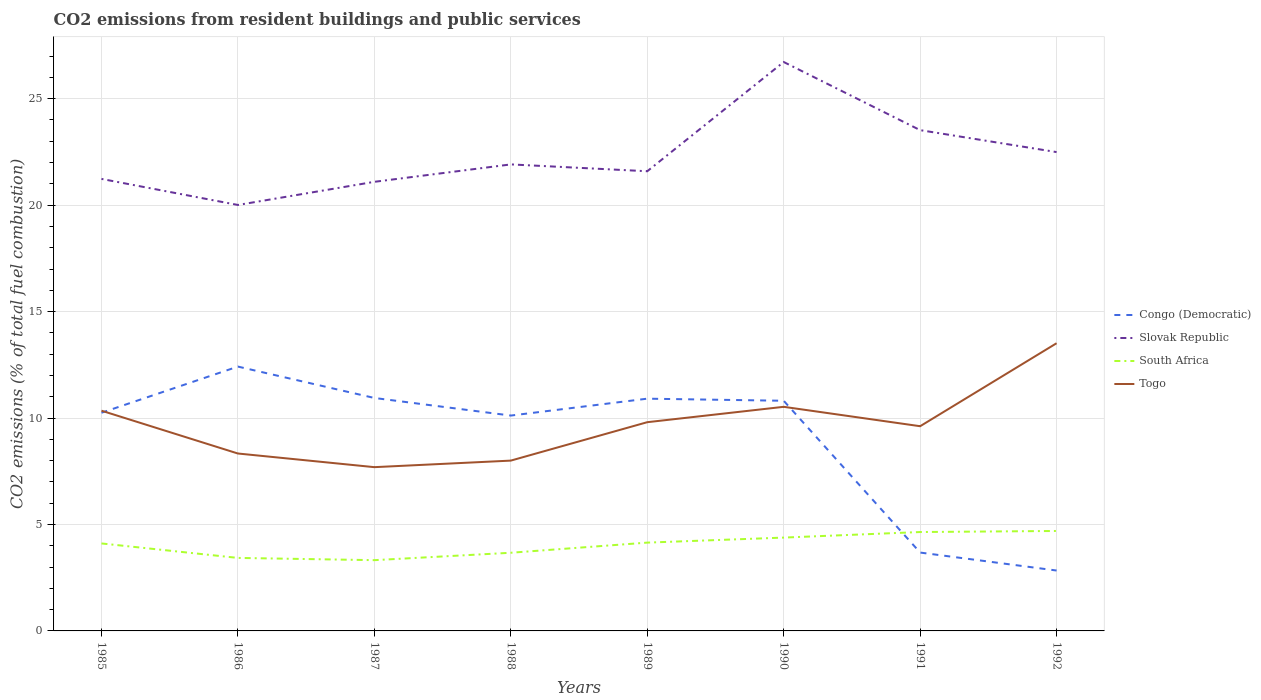How many different coloured lines are there?
Offer a very short reply. 4. Does the line corresponding to Togo intersect with the line corresponding to Slovak Republic?
Ensure brevity in your answer.  No. Across all years, what is the maximum total CO2 emitted in Togo?
Offer a terse response. 7.69. In which year was the total CO2 emitted in Togo maximum?
Ensure brevity in your answer.  1987. What is the total total CO2 emitted in Congo (Democratic) in the graph?
Provide a short and direct response. 1.51. What is the difference between the highest and the second highest total CO2 emitted in Togo?
Keep it short and to the point. 5.82. Is the total CO2 emitted in Togo strictly greater than the total CO2 emitted in Slovak Republic over the years?
Your answer should be compact. Yes. How many lines are there?
Your answer should be compact. 4. How many years are there in the graph?
Offer a very short reply. 8. Where does the legend appear in the graph?
Your response must be concise. Center right. What is the title of the graph?
Offer a very short reply. CO2 emissions from resident buildings and public services. What is the label or title of the Y-axis?
Give a very brief answer. CO2 emissions (% of total fuel combustion). What is the CO2 emissions (% of total fuel combustion) of Congo (Democratic) in 1985?
Provide a succinct answer. 10.25. What is the CO2 emissions (% of total fuel combustion) in Slovak Republic in 1985?
Your answer should be very brief. 21.23. What is the CO2 emissions (% of total fuel combustion) of South Africa in 1985?
Your answer should be compact. 4.11. What is the CO2 emissions (% of total fuel combustion) in Togo in 1985?
Make the answer very short. 10.34. What is the CO2 emissions (% of total fuel combustion) of Congo (Democratic) in 1986?
Give a very brief answer. 12.42. What is the CO2 emissions (% of total fuel combustion) of Slovak Republic in 1986?
Give a very brief answer. 20.01. What is the CO2 emissions (% of total fuel combustion) of South Africa in 1986?
Offer a very short reply. 3.43. What is the CO2 emissions (% of total fuel combustion) in Togo in 1986?
Your answer should be very brief. 8.33. What is the CO2 emissions (% of total fuel combustion) of Congo (Democratic) in 1987?
Give a very brief answer. 10.94. What is the CO2 emissions (% of total fuel combustion) in Slovak Republic in 1987?
Make the answer very short. 21.09. What is the CO2 emissions (% of total fuel combustion) of South Africa in 1987?
Provide a short and direct response. 3.32. What is the CO2 emissions (% of total fuel combustion) of Togo in 1987?
Offer a very short reply. 7.69. What is the CO2 emissions (% of total fuel combustion) in Congo (Democratic) in 1988?
Provide a short and direct response. 10.12. What is the CO2 emissions (% of total fuel combustion) in Slovak Republic in 1988?
Make the answer very short. 21.91. What is the CO2 emissions (% of total fuel combustion) in South Africa in 1988?
Offer a terse response. 3.67. What is the CO2 emissions (% of total fuel combustion) of Congo (Democratic) in 1989?
Your response must be concise. 10.91. What is the CO2 emissions (% of total fuel combustion) in Slovak Republic in 1989?
Your answer should be very brief. 21.59. What is the CO2 emissions (% of total fuel combustion) of South Africa in 1989?
Make the answer very short. 4.15. What is the CO2 emissions (% of total fuel combustion) of Togo in 1989?
Offer a very short reply. 9.8. What is the CO2 emissions (% of total fuel combustion) in Congo (Democratic) in 1990?
Provide a short and direct response. 10.81. What is the CO2 emissions (% of total fuel combustion) in Slovak Republic in 1990?
Make the answer very short. 26.72. What is the CO2 emissions (% of total fuel combustion) in South Africa in 1990?
Ensure brevity in your answer.  4.38. What is the CO2 emissions (% of total fuel combustion) in Togo in 1990?
Your response must be concise. 10.53. What is the CO2 emissions (% of total fuel combustion) in Congo (Democratic) in 1991?
Your answer should be compact. 3.68. What is the CO2 emissions (% of total fuel combustion) of Slovak Republic in 1991?
Your answer should be compact. 23.52. What is the CO2 emissions (% of total fuel combustion) in South Africa in 1991?
Ensure brevity in your answer.  4.65. What is the CO2 emissions (% of total fuel combustion) of Togo in 1991?
Offer a very short reply. 9.62. What is the CO2 emissions (% of total fuel combustion) of Congo (Democratic) in 1992?
Offer a terse response. 2.84. What is the CO2 emissions (% of total fuel combustion) of Slovak Republic in 1992?
Provide a succinct answer. 22.49. What is the CO2 emissions (% of total fuel combustion) of South Africa in 1992?
Keep it short and to the point. 4.69. What is the CO2 emissions (% of total fuel combustion) of Togo in 1992?
Offer a very short reply. 13.51. Across all years, what is the maximum CO2 emissions (% of total fuel combustion) in Congo (Democratic)?
Your answer should be very brief. 12.42. Across all years, what is the maximum CO2 emissions (% of total fuel combustion) of Slovak Republic?
Your answer should be very brief. 26.72. Across all years, what is the maximum CO2 emissions (% of total fuel combustion) in South Africa?
Ensure brevity in your answer.  4.69. Across all years, what is the maximum CO2 emissions (% of total fuel combustion) of Togo?
Keep it short and to the point. 13.51. Across all years, what is the minimum CO2 emissions (% of total fuel combustion) of Congo (Democratic)?
Provide a short and direct response. 2.84. Across all years, what is the minimum CO2 emissions (% of total fuel combustion) in Slovak Republic?
Offer a terse response. 20.01. Across all years, what is the minimum CO2 emissions (% of total fuel combustion) of South Africa?
Your response must be concise. 3.32. Across all years, what is the minimum CO2 emissions (% of total fuel combustion) of Togo?
Make the answer very short. 7.69. What is the total CO2 emissions (% of total fuel combustion) of Congo (Democratic) in the graph?
Give a very brief answer. 71.96. What is the total CO2 emissions (% of total fuel combustion) of Slovak Republic in the graph?
Offer a very short reply. 178.58. What is the total CO2 emissions (% of total fuel combustion) of South Africa in the graph?
Offer a very short reply. 32.41. What is the total CO2 emissions (% of total fuel combustion) in Togo in the graph?
Provide a succinct answer. 77.83. What is the difference between the CO2 emissions (% of total fuel combustion) in Congo (Democratic) in 1985 and that in 1986?
Ensure brevity in your answer.  -2.17. What is the difference between the CO2 emissions (% of total fuel combustion) of Slovak Republic in 1985 and that in 1986?
Give a very brief answer. 1.22. What is the difference between the CO2 emissions (% of total fuel combustion) of South Africa in 1985 and that in 1986?
Make the answer very short. 0.68. What is the difference between the CO2 emissions (% of total fuel combustion) of Togo in 1985 and that in 1986?
Provide a short and direct response. 2.01. What is the difference between the CO2 emissions (% of total fuel combustion) of Congo (Democratic) in 1985 and that in 1987?
Your answer should be compact. -0.69. What is the difference between the CO2 emissions (% of total fuel combustion) in Slovak Republic in 1985 and that in 1987?
Provide a short and direct response. 0.14. What is the difference between the CO2 emissions (% of total fuel combustion) in South Africa in 1985 and that in 1987?
Offer a terse response. 0.79. What is the difference between the CO2 emissions (% of total fuel combustion) in Togo in 1985 and that in 1987?
Provide a short and direct response. 2.65. What is the difference between the CO2 emissions (% of total fuel combustion) in Congo (Democratic) in 1985 and that in 1988?
Keep it short and to the point. 0.13. What is the difference between the CO2 emissions (% of total fuel combustion) in Slovak Republic in 1985 and that in 1988?
Your answer should be very brief. -0.68. What is the difference between the CO2 emissions (% of total fuel combustion) of South Africa in 1985 and that in 1988?
Your answer should be compact. 0.44. What is the difference between the CO2 emissions (% of total fuel combustion) in Togo in 1985 and that in 1988?
Ensure brevity in your answer.  2.34. What is the difference between the CO2 emissions (% of total fuel combustion) in Congo (Democratic) in 1985 and that in 1989?
Your answer should be very brief. -0.66. What is the difference between the CO2 emissions (% of total fuel combustion) in Slovak Republic in 1985 and that in 1989?
Keep it short and to the point. -0.36. What is the difference between the CO2 emissions (% of total fuel combustion) of South Africa in 1985 and that in 1989?
Ensure brevity in your answer.  -0.04. What is the difference between the CO2 emissions (% of total fuel combustion) in Togo in 1985 and that in 1989?
Offer a terse response. 0.54. What is the difference between the CO2 emissions (% of total fuel combustion) of Congo (Democratic) in 1985 and that in 1990?
Make the answer very short. -0.56. What is the difference between the CO2 emissions (% of total fuel combustion) in Slovak Republic in 1985 and that in 1990?
Your response must be concise. -5.49. What is the difference between the CO2 emissions (% of total fuel combustion) in South Africa in 1985 and that in 1990?
Offer a terse response. -0.27. What is the difference between the CO2 emissions (% of total fuel combustion) of Togo in 1985 and that in 1990?
Give a very brief answer. -0.18. What is the difference between the CO2 emissions (% of total fuel combustion) of Congo (Democratic) in 1985 and that in 1991?
Provide a succinct answer. 6.57. What is the difference between the CO2 emissions (% of total fuel combustion) of Slovak Republic in 1985 and that in 1991?
Provide a short and direct response. -2.29. What is the difference between the CO2 emissions (% of total fuel combustion) of South Africa in 1985 and that in 1991?
Give a very brief answer. -0.54. What is the difference between the CO2 emissions (% of total fuel combustion) in Togo in 1985 and that in 1991?
Your answer should be compact. 0.73. What is the difference between the CO2 emissions (% of total fuel combustion) in Congo (Democratic) in 1985 and that in 1992?
Offer a very short reply. 7.41. What is the difference between the CO2 emissions (% of total fuel combustion) in Slovak Republic in 1985 and that in 1992?
Make the answer very short. -1.26. What is the difference between the CO2 emissions (% of total fuel combustion) of South Africa in 1985 and that in 1992?
Provide a succinct answer. -0.59. What is the difference between the CO2 emissions (% of total fuel combustion) of Togo in 1985 and that in 1992?
Make the answer very short. -3.17. What is the difference between the CO2 emissions (% of total fuel combustion) in Congo (Democratic) in 1986 and that in 1987?
Your answer should be compact. 1.47. What is the difference between the CO2 emissions (% of total fuel combustion) of Slovak Republic in 1986 and that in 1987?
Offer a very short reply. -1.09. What is the difference between the CO2 emissions (% of total fuel combustion) in South Africa in 1986 and that in 1987?
Your answer should be very brief. 0.11. What is the difference between the CO2 emissions (% of total fuel combustion) in Togo in 1986 and that in 1987?
Keep it short and to the point. 0.64. What is the difference between the CO2 emissions (% of total fuel combustion) of Congo (Democratic) in 1986 and that in 1988?
Make the answer very short. 2.3. What is the difference between the CO2 emissions (% of total fuel combustion) of Slovak Republic in 1986 and that in 1988?
Your answer should be compact. -1.91. What is the difference between the CO2 emissions (% of total fuel combustion) of South Africa in 1986 and that in 1988?
Offer a very short reply. -0.24. What is the difference between the CO2 emissions (% of total fuel combustion) of Congo (Democratic) in 1986 and that in 1989?
Your answer should be very brief. 1.51. What is the difference between the CO2 emissions (% of total fuel combustion) of Slovak Republic in 1986 and that in 1989?
Provide a short and direct response. -1.58. What is the difference between the CO2 emissions (% of total fuel combustion) in South Africa in 1986 and that in 1989?
Provide a short and direct response. -0.72. What is the difference between the CO2 emissions (% of total fuel combustion) in Togo in 1986 and that in 1989?
Your response must be concise. -1.47. What is the difference between the CO2 emissions (% of total fuel combustion) in Congo (Democratic) in 1986 and that in 1990?
Your response must be concise. 1.61. What is the difference between the CO2 emissions (% of total fuel combustion) of Slovak Republic in 1986 and that in 1990?
Provide a succinct answer. -6.72. What is the difference between the CO2 emissions (% of total fuel combustion) in South Africa in 1986 and that in 1990?
Your response must be concise. -0.95. What is the difference between the CO2 emissions (% of total fuel combustion) of Togo in 1986 and that in 1990?
Your response must be concise. -2.19. What is the difference between the CO2 emissions (% of total fuel combustion) in Congo (Democratic) in 1986 and that in 1991?
Provide a succinct answer. 8.74. What is the difference between the CO2 emissions (% of total fuel combustion) in Slovak Republic in 1986 and that in 1991?
Offer a terse response. -3.51. What is the difference between the CO2 emissions (% of total fuel combustion) of South Africa in 1986 and that in 1991?
Provide a succinct answer. -1.22. What is the difference between the CO2 emissions (% of total fuel combustion) in Togo in 1986 and that in 1991?
Offer a terse response. -1.28. What is the difference between the CO2 emissions (% of total fuel combustion) of Congo (Democratic) in 1986 and that in 1992?
Your answer should be very brief. 9.58. What is the difference between the CO2 emissions (% of total fuel combustion) of Slovak Republic in 1986 and that in 1992?
Provide a succinct answer. -2.48. What is the difference between the CO2 emissions (% of total fuel combustion) in South Africa in 1986 and that in 1992?
Make the answer very short. -1.27. What is the difference between the CO2 emissions (% of total fuel combustion) in Togo in 1986 and that in 1992?
Your response must be concise. -5.18. What is the difference between the CO2 emissions (% of total fuel combustion) of Congo (Democratic) in 1987 and that in 1988?
Provide a succinct answer. 0.83. What is the difference between the CO2 emissions (% of total fuel combustion) in Slovak Republic in 1987 and that in 1988?
Give a very brief answer. -0.82. What is the difference between the CO2 emissions (% of total fuel combustion) in South Africa in 1987 and that in 1988?
Keep it short and to the point. -0.35. What is the difference between the CO2 emissions (% of total fuel combustion) of Togo in 1987 and that in 1988?
Provide a short and direct response. -0.31. What is the difference between the CO2 emissions (% of total fuel combustion) in Congo (Democratic) in 1987 and that in 1989?
Offer a very short reply. 0.03. What is the difference between the CO2 emissions (% of total fuel combustion) in Slovak Republic in 1987 and that in 1989?
Offer a very short reply. -0.5. What is the difference between the CO2 emissions (% of total fuel combustion) in South Africa in 1987 and that in 1989?
Keep it short and to the point. -0.82. What is the difference between the CO2 emissions (% of total fuel combustion) in Togo in 1987 and that in 1989?
Your response must be concise. -2.11. What is the difference between the CO2 emissions (% of total fuel combustion) of Congo (Democratic) in 1987 and that in 1990?
Provide a short and direct response. 0.13. What is the difference between the CO2 emissions (% of total fuel combustion) of Slovak Republic in 1987 and that in 1990?
Keep it short and to the point. -5.63. What is the difference between the CO2 emissions (% of total fuel combustion) in South Africa in 1987 and that in 1990?
Make the answer very short. -1.06. What is the difference between the CO2 emissions (% of total fuel combustion) of Togo in 1987 and that in 1990?
Make the answer very short. -2.83. What is the difference between the CO2 emissions (% of total fuel combustion) in Congo (Democratic) in 1987 and that in 1991?
Your response must be concise. 7.26. What is the difference between the CO2 emissions (% of total fuel combustion) of Slovak Republic in 1987 and that in 1991?
Keep it short and to the point. -2.43. What is the difference between the CO2 emissions (% of total fuel combustion) in South Africa in 1987 and that in 1991?
Provide a succinct answer. -1.32. What is the difference between the CO2 emissions (% of total fuel combustion) in Togo in 1987 and that in 1991?
Your answer should be compact. -1.92. What is the difference between the CO2 emissions (% of total fuel combustion) of Congo (Democratic) in 1987 and that in 1992?
Provide a succinct answer. 8.11. What is the difference between the CO2 emissions (% of total fuel combustion) in Slovak Republic in 1987 and that in 1992?
Your response must be concise. -1.4. What is the difference between the CO2 emissions (% of total fuel combustion) of South Africa in 1987 and that in 1992?
Ensure brevity in your answer.  -1.37. What is the difference between the CO2 emissions (% of total fuel combustion) of Togo in 1987 and that in 1992?
Offer a terse response. -5.82. What is the difference between the CO2 emissions (% of total fuel combustion) in Congo (Democratic) in 1988 and that in 1989?
Offer a very short reply. -0.79. What is the difference between the CO2 emissions (% of total fuel combustion) in Slovak Republic in 1988 and that in 1989?
Your response must be concise. 0.32. What is the difference between the CO2 emissions (% of total fuel combustion) of South Africa in 1988 and that in 1989?
Your answer should be compact. -0.48. What is the difference between the CO2 emissions (% of total fuel combustion) in Togo in 1988 and that in 1989?
Keep it short and to the point. -1.8. What is the difference between the CO2 emissions (% of total fuel combustion) in Congo (Democratic) in 1988 and that in 1990?
Your answer should be compact. -0.7. What is the difference between the CO2 emissions (% of total fuel combustion) in Slovak Republic in 1988 and that in 1990?
Provide a succinct answer. -4.81. What is the difference between the CO2 emissions (% of total fuel combustion) of South Africa in 1988 and that in 1990?
Ensure brevity in your answer.  -0.71. What is the difference between the CO2 emissions (% of total fuel combustion) of Togo in 1988 and that in 1990?
Provide a succinct answer. -2.53. What is the difference between the CO2 emissions (% of total fuel combustion) in Congo (Democratic) in 1988 and that in 1991?
Provide a succinct answer. 6.43. What is the difference between the CO2 emissions (% of total fuel combustion) of Slovak Republic in 1988 and that in 1991?
Keep it short and to the point. -1.61. What is the difference between the CO2 emissions (% of total fuel combustion) of South Africa in 1988 and that in 1991?
Keep it short and to the point. -0.97. What is the difference between the CO2 emissions (% of total fuel combustion) in Togo in 1988 and that in 1991?
Provide a short and direct response. -1.62. What is the difference between the CO2 emissions (% of total fuel combustion) in Congo (Democratic) in 1988 and that in 1992?
Your response must be concise. 7.28. What is the difference between the CO2 emissions (% of total fuel combustion) in Slovak Republic in 1988 and that in 1992?
Keep it short and to the point. -0.58. What is the difference between the CO2 emissions (% of total fuel combustion) of South Africa in 1988 and that in 1992?
Make the answer very short. -1.02. What is the difference between the CO2 emissions (% of total fuel combustion) in Togo in 1988 and that in 1992?
Provide a short and direct response. -5.51. What is the difference between the CO2 emissions (% of total fuel combustion) of Congo (Democratic) in 1989 and that in 1990?
Provide a succinct answer. 0.1. What is the difference between the CO2 emissions (% of total fuel combustion) in Slovak Republic in 1989 and that in 1990?
Keep it short and to the point. -5.13. What is the difference between the CO2 emissions (% of total fuel combustion) of South Africa in 1989 and that in 1990?
Offer a terse response. -0.24. What is the difference between the CO2 emissions (% of total fuel combustion) in Togo in 1989 and that in 1990?
Offer a terse response. -0.72. What is the difference between the CO2 emissions (% of total fuel combustion) in Congo (Democratic) in 1989 and that in 1991?
Your answer should be compact. 7.23. What is the difference between the CO2 emissions (% of total fuel combustion) in Slovak Republic in 1989 and that in 1991?
Keep it short and to the point. -1.93. What is the difference between the CO2 emissions (% of total fuel combustion) in South Africa in 1989 and that in 1991?
Give a very brief answer. -0.5. What is the difference between the CO2 emissions (% of total fuel combustion) of Togo in 1989 and that in 1991?
Provide a succinct answer. 0.19. What is the difference between the CO2 emissions (% of total fuel combustion) in Congo (Democratic) in 1989 and that in 1992?
Make the answer very short. 8.07. What is the difference between the CO2 emissions (% of total fuel combustion) of Slovak Republic in 1989 and that in 1992?
Keep it short and to the point. -0.9. What is the difference between the CO2 emissions (% of total fuel combustion) of South Africa in 1989 and that in 1992?
Keep it short and to the point. -0.55. What is the difference between the CO2 emissions (% of total fuel combustion) of Togo in 1989 and that in 1992?
Your response must be concise. -3.71. What is the difference between the CO2 emissions (% of total fuel combustion) in Congo (Democratic) in 1990 and that in 1991?
Provide a short and direct response. 7.13. What is the difference between the CO2 emissions (% of total fuel combustion) in Slovak Republic in 1990 and that in 1991?
Make the answer very short. 3.2. What is the difference between the CO2 emissions (% of total fuel combustion) in South Africa in 1990 and that in 1991?
Give a very brief answer. -0.26. What is the difference between the CO2 emissions (% of total fuel combustion) in Togo in 1990 and that in 1991?
Ensure brevity in your answer.  0.91. What is the difference between the CO2 emissions (% of total fuel combustion) of Congo (Democratic) in 1990 and that in 1992?
Keep it short and to the point. 7.97. What is the difference between the CO2 emissions (% of total fuel combustion) of Slovak Republic in 1990 and that in 1992?
Give a very brief answer. 4.23. What is the difference between the CO2 emissions (% of total fuel combustion) in South Africa in 1990 and that in 1992?
Give a very brief answer. -0.31. What is the difference between the CO2 emissions (% of total fuel combustion) in Togo in 1990 and that in 1992?
Your answer should be compact. -2.99. What is the difference between the CO2 emissions (% of total fuel combustion) of Congo (Democratic) in 1991 and that in 1992?
Ensure brevity in your answer.  0.84. What is the difference between the CO2 emissions (% of total fuel combustion) of Slovak Republic in 1991 and that in 1992?
Ensure brevity in your answer.  1.03. What is the difference between the CO2 emissions (% of total fuel combustion) in South Africa in 1991 and that in 1992?
Make the answer very short. -0.05. What is the difference between the CO2 emissions (% of total fuel combustion) of Togo in 1991 and that in 1992?
Keep it short and to the point. -3.9. What is the difference between the CO2 emissions (% of total fuel combustion) of Congo (Democratic) in 1985 and the CO2 emissions (% of total fuel combustion) of Slovak Republic in 1986?
Offer a very short reply. -9.76. What is the difference between the CO2 emissions (% of total fuel combustion) of Congo (Democratic) in 1985 and the CO2 emissions (% of total fuel combustion) of South Africa in 1986?
Provide a succinct answer. 6.82. What is the difference between the CO2 emissions (% of total fuel combustion) of Congo (Democratic) in 1985 and the CO2 emissions (% of total fuel combustion) of Togo in 1986?
Offer a very short reply. 1.92. What is the difference between the CO2 emissions (% of total fuel combustion) in Slovak Republic in 1985 and the CO2 emissions (% of total fuel combustion) in South Africa in 1986?
Provide a succinct answer. 17.8. What is the difference between the CO2 emissions (% of total fuel combustion) in Slovak Republic in 1985 and the CO2 emissions (% of total fuel combustion) in Togo in 1986?
Make the answer very short. 12.9. What is the difference between the CO2 emissions (% of total fuel combustion) of South Africa in 1985 and the CO2 emissions (% of total fuel combustion) of Togo in 1986?
Your answer should be very brief. -4.22. What is the difference between the CO2 emissions (% of total fuel combustion) in Congo (Democratic) in 1985 and the CO2 emissions (% of total fuel combustion) in Slovak Republic in 1987?
Give a very brief answer. -10.85. What is the difference between the CO2 emissions (% of total fuel combustion) of Congo (Democratic) in 1985 and the CO2 emissions (% of total fuel combustion) of South Africa in 1987?
Provide a short and direct response. 6.92. What is the difference between the CO2 emissions (% of total fuel combustion) in Congo (Democratic) in 1985 and the CO2 emissions (% of total fuel combustion) in Togo in 1987?
Offer a very short reply. 2.56. What is the difference between the CO2 emissions (% of total fuel combustion) in Slovak Republic in 1985 and the CO2 emissions (% of total fuel combustion) in South Africa in 1987?
Give a very brief answer. 17.91. What is the difference between the CO2 emissions (% of total fuel combustion) of Slovak Republic in 1985 and the CO2 emissions (% of total fuel combustion) of Togo in 1987?
Your answer should be very brief. 13.54. What is the difference between the CO2 emissions (% of total fuel combustion) of South Africa in 1985 and the CO2 emissions (% of total fuel combustion) of Togo in 1987?
Give a very brief answer. -3.58. What is the difference between the CO2 emissions (% of total fuel combustion) of Congo (Democratic) in 1985 and the CO2 emissions (% of total fuel combustion) of Slovak Republic in 1988?
Ensure brevity in your answer.  -11.66. What is the difference between the CO2 emissions (% of total fuel combustion) in Congo (Democratic) in 1985 and the CO2 emissions (% of total fuel combustion) in South Africa in 1988?
Provide a short and direct response. 6.58. What is the difference between the CO2 emissions (% of total fuel combustion) in Congo (Democratic) in 1985 and the CO2 emissions (% of total fuel combustion) in Togo in 1988?
Ensure brevity in your answer.  2.25. What is the difference between the CO2 emissions (% of total fuel combustion) of Slovak Republic in 1985 and the CO2 emissions (% of total fuel combustion) of South Africa in 1988?
Offer a very short reply. 17.56. What is the difference between the CO2 emissions (% of total fuel combustion) of Slovak Republic in 1985 and the CO2 emissions (% of total fuel combustion) of Togo in 1988?
Your response must be concise. 13.23. What is the difference between the CO2 emissions (% of total fuel combustion) of South Africa in 1985 and the CO2 emissions (% of total fuel combustion) of Togo in 1988?
Ensure brevity in your answer.  -3.89. What is the difference between the CO2 emissions (% of total fuel combustion) in Congo (Democratic) in 1985 and the CO2 emissions (% of total fuel combustion) in Slovak Republic in 1989?
Provide a succinct answer. -11.34. What is the difference between the CO2 emissions (% of total fuel combustion) in Congo (Democratic) in 1985 and the CO2 emissions (% of total fuel combustion) in South Africa in 1989?
Offer a terse response. 6.1. What is the difference between the CO2 emissions (% of total fuel combustion) in Congo (Democratic) in 1985 and the CO2 emissions (% of total fuel combustion) in Togo in 1989?
Provide a succinct answer. 0.44. What is the difference between the CO2 emissions (% of total fuel combustion) in Slovak Republic in 1985 and the CO2 emissions (% of total fuel combustion) in South Africa in 1989?
Your response must be concise. 17.08. What is the difference between the CO2 emissions (% of total fuel combustion) in Slovak Republic in 1985 and the CO2 emissions (% of total fuel combustion) in Togo in 1989?
Give a very brief answer. 11.43. What is the difference between the CO2 emissions (% of total fuel combustion) in South Africa in 1985 and the CO2 emissions (% of total fuel combustion) in Togo in 1989?
Your answer should be very brief. -5.69. What is the difference between the CO2 emissions (% of total fuel combustion) in Congo (Democratic) in 1985 and the CO2 emissions (% of total fuel combustion) in Slovak Republic in 1990?
Your response must be concise. -16.47. What is the difference between the CO2 emissions (% of total fuel combustion) of Congo (Democratic) in 1985 and the CO2 emissions (% of total fuel combustion) of South Africa in 1990?
Offer a very short reply. 5.86. What is the difference between the CO2 emissions (% of total fuel combustion) of Congo (Democratic) in 1985 and the CO2 emissions (% of total fuel combustion) of Togo in 1990?
Your answer should be compact. -0.28. What is the difference between the CO2 emissions (% of total fuel combustion) of Slovak Republic in 1985 and the CO2 emissions (% of total fuel combustion) of South Africa in 1990?
Give a very brief answer. 16.85. What is the difference between the CO2 emissions (% of total fuel combustion) in Slovak Republic in 1985 and the CO2 emissions (% of total fuel combustion) in Togo in 1990?
Your answer should be very brief. 10.71. What is the difference between the CO2 emissions (% of total fuel combustion) in South Africa in 1985 and the CO2 emissions (% of total fuel combustion) in Togo in 1990?
Make the answer very short. -6.42. What is the difference between the CO2 emissions (% of total fuel combustion) in Congo (Democratic) in 1985 and the CO2 emissions (% of total fuel combustion) in Slovak Republic in 1991?
Make the answer very short. -13.27. What is the difference between the CO2 emissions (% of total fuel combustion) in Congo (Democratic) in 1985 and the CO2 emissions (% of total fuel combustion) in South Africa in 1991?
Your answer should be compact. 5.6. What is the difference between the CO2 emissions (% of total fuel combustion) of Congo (Democratic) in 1985 and the CO2 emissions (% of total fuel combustion) of Togo in 1991?
Give a very brief answer. 0.63. What is the difference between the CO2 emissions (% of total fuel combustion) in Slovak Republic in 1985 and the CO2 emissions (% of total fuel combustion) in South Africa in 1991?
Ensure brevity in your answer.  16.59. What is the difference between the CO2 emissions (% of total fuel combustion) in Slovak Republic in 1985 and the CO2 emissions (% of total fuel combustion) in Togo in 1991?
Your answer should be very brief. 11.62. What is the difference between the CO2 emissions (% of total fuel combustion) in South Africa in 1985 and the CO2 emissions (% of total fuel combustion) in Togo in 1991?
Give a very brief answer. -5.51. What is the difference between the CO2 emissions (% of total fuel combustion) of Congo (Democratic) in 1985 and the CO2 emissions (% of total fuel combustion) of Slovak Republic in 1992?
Your answer should be compact. -12.24. What is the difference between the CO2 emissions (% of total fuel combustion) in Congo (Democratic) in 1985 and the CO2 emissions (% of total fuel combustion) in South Africa in 1992?
Your response must be concise. 5.55. What is the difference between the CO2 emissions (% of total fuel combustion) of Congo (Democratic) in 1985 and the CO2 emissions (% of total fuel combustion) of Togo in 1992?
Offer a very short reply. -3.27. What is the difference between the CO2 emissions (% of total fuel combustion) of Slovak Republic in 1985 and the CO2 emissions (% of total fuel combustion) of South Africa in 1992?
Your answer should be compact. 16.54. What is the difference between the CO2 emissions (% of total fuel combustion) of Slovak Republic in 1985 and the CO2 emissions (% of total fuel combustion) of Togo in 1992?
Ensure brevity in your answer.  7.72. What is the difference between the CO2 emissions (% of total fuel combustion) in South Africa in 1985 and the CO2 emissions (% of total fuel combustion) in Togo in 1992?
Offer a terse response. -9.4. What is the difference between the CO2 emissions (% of total fuel combustion) in Congo (Democratic) in 1986 and the CO2 emissions (% of total fuel combustion) in Slovak Republic in 1987?
Keep it short and to the point. -8.68. What is the difference between the CO2 emissions (% of total fuel combustion) of Congo (Democratic) in 1986 and the CO2 emissions (% of total fuel combustion) of South Africa in 1987?
Offer a very short reply. 9.09. What is the difference between the CO2 emissions (% of total fuel combustion) of Congo (Democratic) in 1986 and the CO2 emissions (% of total fuel combustion) of Togo in 1987?
Your answer should be compact. 4.72. What is the difference between the CO2 emissions (% of total fuel combustion) of Slovak Republic in 1986 and the CO2 emissions (% of total fuel combustion) of South Africa in 1987?
Offer a very short reply. 16.68. What is the difference between the CO2 emissions (% of total fuel combustion) of Slovak Republic in 1986 and the CO2 emissions (% of total fuel combustion) of Togo in 1987?
Provide a succinct answer. 12.32. What is the difference between the CO2 emissions (% of total fuel combustion) in South Africa in 1986 and the CO2 emissions (% of total fuel combustion) in Togo in 1987?
Your answer should be very brief. -4.26. What is the difference between the CO2 emissions (% of total fuel combustion) in Congo (Democratic) in 1986 and the CO2 emissions (% of total fuel combustion) in Slovak Republic in 1988?
Make the answer very short. -9.5. What is the difference between the CO2 emissions (% of total fuel combustion) in Congo (Democratic) in 1986 and the CO2 emissions (% of total fuel combustion) in South Africa in 1988?
Provide a short and direct response. 8.74. What is the difference between the CO2 emissions (% of total fuel combustion) in Congo (Democratic) in 1986 and the CO2 emissions (% of total fuel combustion) in Togo in 1988?
Your answer should be very brief. 4.42. What is the difference between the CO2 emissions (% of total fuel combustion) of Slovak Republic in 1986 and the CO2 emissions (% of total fuel combustion) of South Africa in 1988?
Make the answer very short. 16.34. What is the difference between the CO2 emissions (% of total fuel combustion) of Slovak Republic in 1986 and the CO2 emissions (% of total fuel combustion) of Togo in 1988?
Make the answer very short. 12.01. What is the difference between the CO2 emissions (% of total fuel combustion) of South Africa in 1986 and the CO2 emissions (% of total fuel combustion) of Togo in 1988?
Offer a terse response. -4.57. What is the difference between the CO2 emissions (% of total fuel combustion) in Congo (Democratic) in 1986 and the CO2 emissions (% of total fuel combustion) in Slovak Republic in 1989?
Your answer should be compact. -9.18. What is the difference between the CO2 emissions (% of total fuel combustion) of Congo (Democratic) in 1986 and the CO2 emissions (% of total fuel combustion) of South Africa in 1989?
Offer a terse response. 8.27. What is the difference between the CO2 emissions (% of total fuel combustion) in Congo (Democratic) in 1986 and the CO2 emissions (% of total fuel combustion) in Togo in 1989?
Keep it short and to the point. 2.61. What is the difference between the CO2 emissions (% of total fuel combustion) of Slovak Republic in 1986 and the CO2 emissions (% of total fuel combustion) of South Africa in 1989?
Provide a short and direct response. 15.86. What is the difference between the CO2 emissions (% of total fuel combustion) of Slovak Republic in 1986 and the CO2 emissions (% of total fuel combustion) of Togo in 1989?
Your answer should be very brief. 10.2. What is the difference between the CO2 emissions (% of total fuel combustion) of South Africa in 1986 and the CO2 emissions (% of total fuel combustion) of Togo in 1989?
Ensure brevity in your answer.  -6.37. What is the difference between the CO2 emissions (% of total fuel combustion) in Congo (Democratic) in 1986 and the CO2 emissions (% of total fuel combustion) in Slovak Republic in 1990?
Your response must be concise. -14.31. What is the difference between the CO2 emissions (% of total fuel combustion) of Congo (Democratic) in 1986 and the CO2 emissions (% of total fuel combustion) of South Africa in 1990?
Your answer should be very brief. 8.03. What is the difference between the CO2 emissions (% of total fuel combustion) in Congo (Democratic) in 1986 and the CO2 emissions (% of total fuel combustion) in Togo in 1990?
Offer a terse response. 1.89. What is the difference between the CO2 emissions (% of total fuel combustion) of Slovak Republic in 1986 and the CO2 emissions (% of total fuel combustion) of South Africa in 1990?
Provide a short and direct response. 15.62. What is the difference between the CO2 emissions (% of total fuel combustion) in Slovak Republic in 1986 and the CO2 emissions (% of total fuel combustion) in Togo in 1990?
Your answer should be very brief. 9.48. What is the difference between the CO2 emissions (% of total fuel combustion) in South Africa in 1986 and the CO2 emissions (% of total fuel combustion) in Togo in 1990?
Ensure brevity in your answer.  -7.1. What is the difference between the CO2 emissions (% of total fuel combustion) of Congo (Democratic) in 1986 and the CO2 emissions (% of total fuel combustion) of Slovak Republic in 1991?
Give a very brief answer. -11.11. What is the difference between the CO2 emissions (% of total fuel combustion) in Congo (Democratic) in 1986 and the CO2 emissions (% of total fuel combustion) in South Africa in 1991?
Offer a very short reply. 7.77. What is the difference between the CO2 emissions (% of total fuel combustion) of Congo (Democratic) in 1986 and the CO2 emissions (% of total fuel combustion) of Togo in 1991?
Provide a succinct answer. 2.8. What is the difference between the CO2 emissions (% of total fuel combustion) in Slovak Republic in 1986 and the CO2 emissions (% of total fuel combustion) in South Africa in 1991?
Offer a terse response. 15.36. What is the difference between the CO2 emissions (% of total fuel combustion) in Slovak Republic in 1986 and the CO2 emissions (% of total fuel combustion) in Togo in 1991?
Offer a terse response. 10.39. What is the difference between the CO2 emissions (% of total fuel combustion) in South Africa in 1986 and the CO2 emissions (% of total fuel combustion) in Togo in 1991?
Your answer should be compact. -6.19. What is the difference between the CO2 emissions (% of total fuel combustion) of Congo (Democratic) in 1986 and the CO2 emissions (% of total fuel combustion) of Slovak Republic in 1992?
Provide a succinct answer. -10.08. What is the difference between the CO2 emissions (% of total fuel combustion) of Congo (Democratic) in 1986 and the CO2 emissions (% of total fuel combustion) of South Africa in 1992?
Give a very brief answer. 7.72. What is the difference between the CO2 emissions (% of total fuel combustion) of Congo (Democratic) in 1986 and the CO2 emissions (% of total fuel combustion) of Togo in 1992?
Your answer should be compact. -1.1. What is the difference between the CO2 emissions (% of total fuel combustion) of Slovak Republic in 1986 and the CO2 emissions (% of total fuel combustion) of South Africa in 1992?
Provide a short and direct response. 15.31. What is the difference between the CO2 emissions (% of total fuel combustion) in Slovak Republic in 1986 and the CO2 emissions (% of total fuel combustion) in Togo in 1992?
Your answer should be compact. 6.49. What is the difference between the CO2 emissions (% of total fuel combustion) of South Africa in 1986 and the CO2 emissions (% of total fuel combustion) of Togo in 1992?
Your answer should be very brief. -10.08. What is the difference between the CO2 emissions (% of total fuel combustion) of Congo (Democratic) in 1987 and the CO2 emissions (% of total fuel combustion) of Slovak Republic in 1988?
Give a very brief answer. -10.97. What is the difference between the CO2 emissions (% of total fuel combustion) of Congo (Democratic) in 1987 and the CO2 emissions (% of total fuel combustion) of South Africa in 1988?
Provide a succinct answer. 7.27. What is the difference between the CO2 emissions (% of total fuel combustion) of Congo (Democratic) in 1987 and the CO2 emissions (% of total fuel combustion) of Togo in 1988?
Offer a terse response. 2.94. What is the difference between the CO2 emissions (% of total fuel combustion) of Slovak Republic in 1987 and the CO2 emissions (% of total fuel combustion) of South Africa in 1988?
Give a very brief answer. 17.42. What is the difference between the CO2 emissions (% of total fuel combustion) in Slovak Republic in 1987 and the CO2 emissions (% of total fuel combustion) in Togo in 1988?
Offer a very short reply. 13.09. What is the difference between the CO2 emissions (% of total fuel combustion) in South Africa in 1987 and the CO2 emissions (% of total fuel combustion) in Togo in 1988?
Your answer should be very brief. -4.68. What is the difference between the CO2 emissions (% of total fuel combustion) of Congo (Democratic) in 1987 and the CO2 emissions (% of total fuel combustion) of Slovak Republic in 1989?
Give a very brief answer. -10.65. What is the difference between the CO2 emissions (% of total fuel combustion) of Congo (Democratic) in 1987 and the CO2 emissions (% of total fuel combustion) of South Africa in 1989?
Give a very brief answer. 6.79. What is the difference between the CO2 emissions (% of total fuel combustion) in Congo (Democratic) in 1987 and the CO2 emissions (% of total fuel combustion) in Togo in 1989?
Your response must be concise. 1.14. What is the difference between the CO2 emissions (% of total fuel combustion) in Slovak Republic in 1987 and the CO2 emissions (% of total fuel combustion) in South Africa in 1989?
Provide a succinct answer. 16.95. What is the difference between the CO2 emissions (% of total fuel combustion) of Slovak Republic in 1987 and the CO2 emissions (% of total fuel combustion) of Togo in 1989?
Your answer should be compact. 11.29. What is the difference between the CO2 emissions (% of total fuel combustion) in South Africa in 1987 and the CO2 emissions (% of total fuel combustion) in Togo in 1989?
Provide a short and direct response. -6.48. What is the difference between the CO2 emissions (% of total fuel combustion) of Congo (Democratic) in 1987 and the CO2 emissions (% of total fuel combustion) of Slovak Republic in 1990?
Ensure brevity in your answer.  -15.78. What is the difference between the CO2 emissions (% of total fuel combustion) in Congo (Democratic) in 1987 and the CO2 emissions (% of total fuel combustion) in South Africa in 1990?
Your answer should be compact. 6.56. What is the difference between the CO2 emissions (% of total fuel combustion) in Congo (Democratic) in 1987 and the CO2 emissions (% of total fuel combustion) in Togo in 1990?
Offer a very short reply. 0.42. What is the difference between the CO2 emissions (% of total fuel combustion) of Slovak Republic in 1987 and the CO2 emissions (% of total fuel combustion) of South Africa in 1990?
Make the answer very short. 16.71. What is the difference between the CO2 emissions (% of total fuel combustion) of Slovak Republic in 1987 and the CO2 emissions (% of total fuel combustion) of Togo in 1990?
Provide a short and direct response. 10.57. What is the difference between the CO2 emissions (% of total fuel combustion) in South Africa in 1987 and the CO2 emissions (% of total fuel combustion) in Togo in 1990?
Give a very brief answer. -7.2. What is the difference between the CO2 emissions (% of total fuel combustion) of Congo (Democratic) in 1987 and the CO2 emissions (% of total fuel combustion) of Slovak Republic in 1991?
Your answer should be very brief. -12.58. What is the difference between the CO2 emissions (% of total fuel combustion) in Congo (Democratic) in 1987 and the CO2 emissions (% of total fuel combustion) in South Africa in 1991?
Your answer should be very brief. 6.3. What is the difference between the CO2 emissions (% of total fuel combustion) in Congo (Democratic) in 1987 and the CO2 emissions (% of total fuel combustion) in Togo in 1991?
Provide a succinct answer. 1.33. What is the difference between the CO2 emissions (% of total fuel combustion) in Slovak Republic in 1987 and the CO2 emissions (% of total fuel combustion) in South Africa in 1991?
Make the answer very short. 16.45. What is the difference between the CO2 emissions (% of total fuel combustion) of Slovak Republic in 1987 and the CO2 emissions (% of total fuel combustion) of Togo in 1991?
Your answer should be very brief. 11.48. What is the difference between the CO2 emissions (% of total fuel combustion) of South Africa in 1987 and the CO2 emissions (% of total fuel combustion) of Togo in 1991?
Keep it short and to the point. -6.29. What is the difference between the CO2 emissions (% of total fuel combustion) of Congo (Democratic) in 1987 and the CO2 emissions (% of total fuel combustion) of Slovak Republic in 1992?
Your response must be concise. -11.55. What is the difference between the CO2 emissions (% of total fuel combustion) of Congo (Democratic) in 1987 and the CO2 emissions (% of total fuel combustion) of South Africa in 1992?
Your response must be concise. 6.25. What is the difference between the CO2 emissions (% of total fuel combustion) of Congo (Democratic) in 1987 and the CO2 emissions (% of total fuel combustion) of Togo in 1992?
Your response must be concise. -2.57. What is the difference between the CO2 emissions (% of total fuel combustion) in Slovak Republic in 1987 and the CO2 emissions (% of total fuel combustion) in South Africa in 1992?
Provide a short and direct response. 16.4. What is the difference between the CO2 emissions (% of total fuel combustion) of Slovak Republic in 1987 and the CO2 emissions (% of total fuel combustion) of Togo in 1992?
Your answer should be very brief. 7.58. What is the difference between the CO2 emissions (% of total fuel combustion) in South Africa in 1987 and the CO2 emissions (% of total fuel combustion) in Togo in 1992?
Offer a very short reply. -10.19. What is the difference between the CO2 emissions (% of total fuel combustion) of Congo (Democratic) in 1988 and the CO2 emissions (% of total fuel combustion) of Slovak Republic in 1989?
Provide a succinct answer. -11.48. What is the difference between the CO2 emissions (% of total fuel combustion) of Congo (Democratic) in 1988 and the CO2 emissions (% of total fuel combustion) of South Africa in 1989?
Offer a terse response. 5.97. What is the difference between the CO2 emissions (% of total fuel combustion) of Congo (Democratic) in 1988 and the CO2 emissions (% of total fuel combustion) of Togo in 1989?
Provide a short and direct response. 0.31. What is the difference between the CO2 emissions (% of total fuel combustion) in Slovak Republic in 1988 and the CO2 emissions (% of total fuel combustion) in South Africa in 1989?
Keep it short and to the point. 17.77. What is the difference between the CO2 emissions (% of total fuel combustion) in Slovak Republic in 1988 and the CO2 emissions (% of total fuel combustion) in Togo in 1989?
Offer a terse response. 12.11. What is the difference between the CO2 emissions (% of total fuel combustion) of South Africa in 1988 and the CO2 emissions (% of total fuel combustion) of Togo in 1989?
Give a very brief answer. -6.13. What is the difference between the CO2 emissions (% of total fuel combustion) in Congo (Democratic) in 1988 and the CO2 emissions (% of total fuel combustion) in Slovak Republic in 1990?
Make the answer very short. -16.61. What is the difference between the CO2 emissions (% of total fuel combustion) of Congo (Democratic) in 1988 and the CO2 emissions (% of total fuel combustion) of South Africa in 1990?
Keep it short and to the point. 5.73. What is the difference between the CO2 emissions (% of total fuel combustion) in Congo (Democratic) in 1988 and the CO2 emissions (% of total fuel combustion) in Togo in 1990?
Your answer should be compact. -0.41. What is the difference between the CO2 emissions (% of total fuel combustion) of Slovak Republic in 1988 and the CO2 emissions (% of total fuel combustion) of South Africa in 1990?
Make the answer very short. 17.53. What is the difference between the CO2 emissions (% of total fuel combustion) of Slovak Republic in 1988 and the CO2 emissions (% of total fuel combustion) of Togo in 1990?
Offer a terse response. 11.39. What is the difference between the CO2 emissions (% of total fuel combustion) in South Africa in 1988 and the CO2 emissions (% of total fuel combustion) in Togo in 1990?
Your response must be concise. -6.85. What is the difference between the CO2 emissions (% of total fuel combustion) in Congo (Democratic) in 1988 and the CO2 emissions (% of total fuel combustion) in Slovak Republic in 1991?
Provide a succinct answer. -13.41. What is the difference between the CO2 emissions (% of total fuel combustion) in Congo (Democratic) in 1988 and the CO2 emissions (% of total fuel combustion) in South Africa in 1991?
Your answer should be very brief. 5.47. What is the difference between the CO2 emissions (% of total fuel combustion) in Congo (Democratic) in 1988 and the CO2 emissions (% of total fuel combustion) in Togo in 1991?
Offer a terse response. 0.5. What is the difference between the CO2 emissions (% of total fuel combustion) of Slovak Republic in 1988 and the CO2 emissions (% of total fuel combustion) of South Africa in 1991?
Your answer should be very brief. 17.27. What is the difference between the CO2 emissions (% of total fuel combustion) in Slovak Republic in 1988 and the CO2 emissions (% of total fuel combustion) in Togo in 1991?
Provide a succinct answer. 12.3. What is the difference between the CO2 emissions (% of total fuel combustion) of South Africa in 1988 and the CO2 emissions (% of total fuel combustion) of Togo in 1991?
Give a very brief answer. -5.94. What is the difference between the CO2 emissions (% of total fuel combustion) of Congo (Democratic) in 1988 and the CO2 emissions (% of total fuel combustion) of Slovak Republic in 1992?
Give a very brief answer. -12.38. What is the difference between the CO2 emissions (% of total fuel combustion) of Congo (Democratic) in 1988 and the CO2 emissions (% of total fuel combustion) of South Africa in 1992?
Provide a short and direct response. 5.42. What is the difference between the CO2 emissions (% of total fuel combustion) in Congo (Democratic) in 1988 and the CO2 emissions (% of total fuel combustion) in Togo in 1992?
Offer a terse response. -3.4. What is the difference between the CO2 emissions (% of total fuel combustion) in Slovak Republic in 1988 and the CO2 emissions (% of total fuel combustion) in South Africa in 1992?
Offer a very short reply. 17.22. What is the difference between the CO2 emissions (% of total fuel combustion) in Slovak Republic in 1988 and the CO2 emissions (% of total fuel combustion) in Togo in 1992?
Ensure brevity in your answer.  8.4. What is the difference between the CO2 emissions (% of total fuel combustion) in South Africa in 1988 and the CO2 emissions (% of total fuel combustion) in Togo in 1992?
Provide a short and direct response. -9.84. What is the difference between the CO2 emissions (% of total fuel combustion) of Congo (Democratic) in 1989 and the CO2 emissions (% of total fuel combustion) of Slovak Republic in 1990?
Offer a very short reply. -15.81. What is the difference between the CO2 emissions (% of total fuel combustion) in Congo (Democratic) in 1989 and the CO2 emissions (% of total fuel combustion) in South Africa in 1990?
Keep it short and to the point. 6.53. What is the difference between the CO2 emissions (% of total fuel combustion) of Congo (Democratic) in 1989 and the CO2 emissions (% of total fuel combustion) of Togo in 1990?
Your answer should be very brief. 0.38. What is the difference between the CO2 emissions (% of total fuel combustion) in Slovak Republic in 1989 and the CO2 emissions (% of total fuel combustion) in South Africa in 1990?
Provide a succinct answer. 17.21. What is the difference between the CO2 emissions (% of total fuel combustion) of Slovak Republic in 1989 and the CO2 emissions (% of total fuel combustion) of Togo in 1990?
Provide a short and direct response. 11.07. What is the difference between the CO2 emissions (% of total fuel combustion) of South Africa in 1989 and the CO2 emissions (% of total fuel combustion) of Togo in 1990?
Your answer should be very brief. -6.38. What is the difference between the CO2 emissions (% of total fuel combustion) of Congo (Democratic) in 1989 and the CO2 emissions (% of total fuel combustion) of Slovak Republic in 1991?
Provide a succinct answer. -12.61. What is the difference between the CO2 emissions (% of total fuel combustion) of Congo (Democratic) in 1989 and the CO2 emissions (% of total fuel combustion) of South Africa in 1991?
Ensure brevity in your answer.  6.26. What is the difference between the CO2 emissions (% of total fuel combustion) in Congo (Democratic) in 1989 and the CO2 emissions (% of total fuel combustion) in Togo in 1991?
Your answer should be compact. 1.29. What is the difference between the CO2 emissions (% of total fuel combustion) in Slovak Republic in 1989 and the CO2 emissions (% of total fuel combustion) in South Africa in 1991?
Ensure brevity in your answer.  16.95. What is the difference between the CO2 emissions (% of total fuel combustion) of Slovak Republic in 1989 and the CO2 emissions (% of total fuel combustion) of Togo in 1991?
Keep it short and to the point. 11.98. What is the difference between the CO2 emissions (% of total fuel combustion) of South Africa in 1989 and the CO2 emissions (% of total fuel combustion) of Togo in 1991?
Provide a short and direct response. -5.47. What is the difference between the CO2 emissions (% of total fuel combustion) of Congo (Democratic) in 1989 and the CO2 emissions (% of total fuel combustion) of Slovak Republic in 1992?
Your answer should be very brief. -11.58. What is the difference between the CO2 emissions (% of total fuel combustion) of Congo (Democratic) in 1989 and the CO2 emissions (% of total fuel combustion) of South Africa in 1992?
Ensure brevity in your answer.  6.21. What is the difference between the CO2 emissions (% of total fuel combustion) in Congo (Democratic) in 1989 and the CO2 emissions (% of total fuel combustion) in Togo in 1992?
Offer a very short reply. -2.6. What is the difference between the CO2 emissions (% of total fuel combustion) in Slovak Republic in 1989 and the CO2 emissions (% of total fuel combustion) in South Africa in 1992?
Keep it short and to the point. 16.9. What is the difference between the CO2 emissions (% of total fuel combustion) of Slovak Republic in 1989 and the CO2 emissions (% of total fuel combustion) of Togo in 1992?
Make the answer very short. 8.08. What is the difference between the CO2 emissions (% of total fuel combustion) in South Africa in 1989 and the CO2 emissions (% of total fuel combustion) in Togo in 1992?
Offer a terse response. -9.37. What is the difference between the CO2 emissions (% of total fuel combustion) in Congo (Democratic) in 1990 and the CO2 emissions (% of total fuel combustion) in Slovak Republic in 1991?
Your answer should be very brief. -12.71. What is the difference between the CO2 emissions (% of total fuel combustion) of Congo (Democratic) in 1990 and the CO2 emissions (% of total fuel combustion) of South Africa in 1991?
Your answer should be very brief. 6.17. What is the difference between the CO2 emissions (% of total fuel combustion) of Congo (Democratic) in 1990 and the CO2 emissions (% of total fuel combustion) of Togo in 1991?
Provide a short and direct response. 1.2. What is the difference between the CO2 emissions (% of total fuel combustion) of Slovak Republic in 1990 and the CO2 emissions (% of total fuel combustion) of South Africa in 1991?
Provide a short and direct response. 22.08. What is the difference between the CO2 emissions (% of total fuel combustion) in Slovak Republic in 1990 and the CO2 emissions (% of total fuel combustion) in Togo in 1991?
Your answer should be very brief. 17.11. What is the difference between the CO2 emissions (% of total fuel combustion) of South Africa in 1990 and the CO2 emissions (% of total fuel combustion) of Togo in 1991?
Offer a terse response. -5.23. What is the difference between the CO2 emissions (% of total fuel combustion) of Congo (Democratic) in 1990 and the CO2 emissions (% of total fuel combustion) of Slovak Republic in 1992?
Offer a terse response. -11.68. What is the difference between the CO2 emissions (% of total fuel combustion) in Congo (Democratic) in 1990 and the CO2 emissions (% of total fuel combustion) in South Africa in 1992?
Offer a very short reply. 6.12. What is the difference between the CO2 emissions (% of total fuel combustion) in Congo (Democratic) in 1990 and the CO2 emissions (% of total fuel combustion) in Togo in 1992?
Give a very brief answer. -2.7. What is the difference between the CO2 emissions (% of total fuel combustion) in Slovak Republic in 1990 and the CO2 emissions (% of total fuel combustion) in South Africa in 1992?
Ensure brevity in your answer.  22.03. What is the difference between the CO2 emissions (% of total fuel combustion) of Slovak Republic in 1990 and the CO2 emissions (% of total fuel combustion) of Togo in 1992?
Provide a succinct answer. 13.21. What is the difference between the CO2 emissions (% of total fuel combustion) of South Africa in 1990 and the CO2 emissions (% of total fuel combustion) of Togo in 1992?
Make the answer very short. -9.13. What is the difference between the CO2 emissions (% of total fuel combustion) in Congo (Democratic) in 1991 and the CO2 emissions (% of total fuel combustion) in Slovak Republic in 1992?
Give a very brief answer. -18.81. What is the difference between the CO2 emissions (% of total fuel combustion) of Congo (Democratic) in 1991 and the CO2 emissions (% of total fuel combustion) of South Africa in 1992?
Your response must be concise. -1.01. What is the difference between the CO2 emissions (% of total fuel combustion) in Congo (Democratic) in 1991 and the CO2 emissions (% of total fuel combustion) in Togo in 1992?
Offer a terse response. -9.83. What is the difference between the CO2 emissions (% of total fuel combustion) of Slovak Republic in 1991 and the CO2 emissions (% of total fuel combustion) of South Africa in 1992?
Make the answer very short. 18.83. What is the difference between the CO2 emissions (% of total fuel combustion) of Slovak Republic in 1991 and the CO2 emissions (% of total fuel combustion) of Togo in 1992?
Your answer should be very brief. 10.01. What is the difference between the CO2 emissions (% of total fuel combustion) of South Africa in 1991 and the CO2 emissions (% of total fuel combustion) of Togo in 1992?
Your answer should be compact. -8.87. What is the average CO2 emissions (% of total fuel combustion) in Congo (Democratic) per year?
Your answer should be compact. 8.99. What is the average CO2 emissions (% of total fuel combustion) of Slovak Republic per year?
Your answer should be very brief. 22.32. What is the average CO2 emissions (% of total fuel combustion) of South Africa per year?
Your response must be concise. 4.05. What is the average CO2 emissions (% of total fuel combustion) of Togo per year?
Give a very brief answer. 9.73. In the year 1985, what is the difference between the CO2 emissions (% of total fuel combustion) of Congo (Democratic) and CO2 emissions (% of total fuel combustion) of Slovak Republic?
Ensure brevity in your answer.  -10.98. In the year 1985, what is the difference between the CO2 emissions (% of total fuel combustion) in Congo (Democratic) and CO2 emissions (% of total fuel combustion) in South Africa?
Your response must be concise. 6.14. In the year 1985, what is the difference between the CO2 emissions (% of total fuel combustion) in Congo (Democratic) and CO2 emissions (% of total fuel combustion) in Togo?
Your answer should be very brief. -0.1. In the year 1985, what is the difference between the CO2 emissions (% of total fuel combustion) of Slovak Republic and CO2 emissions (% of total fuel combustion) of South Africa?
Give a very brief answer. 17.12. In the year 1985, what is the difference between the CO2 emissions (% of total fuel combustion) in Slovak Republic and CO2 emissions (% of total fuel combustion) in Togo?
Offer a terse response. 10.89. In the year 1985, what is the difference between the CO2 emissions (% of total fuel combustion) of South Africa and CO2 emissions (% of total fuel combustion) of Togo?
Provide a succinct answer. -6.24. In the year 1986, what is the difference between the CO2 emissions (% of total fuel combustion) in Congo (Democratic) and CO2 emissions (% of total fuel combustion) in Slovak Republic?
Provide a succinct answer. -7.59. In the year 1986, what is the difference between the CO2 emissions (% of total fuel combustion) in Congo (Democratic) and CO2 emissions (% of total fuel combustion) in South Africa?
Provide a short and direct response. 8.99. In the year 1986, what is the difference between the CO2 emissions (% of total fuel combustion) in Congo (Democratic) and CO2 emissions (% of total fuel combustion) in Togo?
Provide a short and direct response. 4.08. In the year 1986, what is the difference between the CO2 emissions (% of total fuel combustion) of Slovak Republic and CO2 emissions (% of total fuel combustion) of South Africa?
Provide a succinct answer. 16.58. In the year 1986, what is the difference between the CO2 emissions (% of total fuel combustion) of Slovak Republic and CO2 emissions (% of total fuel combustion) of Togo?
Give a very brief answer. 11.67. In the year 1986, what is the difference between the CO2 emissions (% of total fuel combustion) in South Africa and CO2 emissions (% of total fuel combustion) in Togo?
Your response must be concise. -4.9. In the year 1987, what is the difference between the CO2 emissions (% of total fuel combustion) in Congo (Democratic) and CO2 emissions (% of total fuel combustion) in Slovak Republic?
Provide a short and direct response. -10.15. In the year 1987, what is the difference between the CO2 emissions (% of total fuel combustion) of Congo (Democratic) and CO2 emissions (% of total fuel combustion) of South Africa?
Give a very brief answer. 7.62. In the year 1987, what is the difference between the CO2 emissions (% of total fuel combustion) of Congo (Democratic) and CO2 emissions (% of total fuel combustion) of Togo?
Ensure brevity in your answer.  3.25. In the year 1987, what is the difference between the CO2 emissions (% of total fuel combustion) of Slovak Republic and CO2 emissions (% of total fuel combustion) of South Africa?
Provide a succinct answer. 17.77. In the year 1987, what is the difference between the CO2 emissions (% of total fuel combustion) of Slovak Republic and CO2 emissions (% of total fuel combustion) of Togo?
Provide a short and direct response. 13.4. In the year 1987, what is the difference between the CO2 emissions (% of total fuel combustion) of South Africa and CO2 emissions (% of total fuel combustion) of Togo?
Provide a succinct answer. -4.37. In the year 1988, what is the difference between the CO2 emissions (% of total fuel combustion) in Congo (Democratic) and CO2 emissions (% of total fuel combustion) in Slovak Republic?
Provide a short and direct response. -11.8. In the year 1988, what is the difference between the CO2 emissions (% of total fuel combustion) of Congo (Democratic) and CO2 emissions (% of total fuel combustion) of South Africa?
Give a very brief answer. 6.44. In the year 1988, what is the difference between the CO2 emissions (% of total fuel combustion) in Congo (Democratic) and CO2 emissions (% of total fuel combustion) in Togo?
Your response must be concise. 2.12. In the year 1988, what is the difference between the CO2 emissions (% of total fuel combustion) in Slovak Republic and CO2 emissions (% of total fuel combustion) in South Africa?
Your answer should be compact. 18.24. In the year 1988, what is the difference between the CO2 emissions (% of total fuel combustion) of Slovak Republic and CO2 emissions (% of total fuel combustion) of Togo?
Offer a very short reply. 13.91. In the year 1988, what is the difference between the CO2 emissions (% of total fuel combustion) of South Africa and CO2 emissions (% of total fuel combustion) of Togo?
Your answer should be compact. -4.33. In the year 1989, what is the difference between the CO2 emissions (% of total fuel combustion) of Congo (Democratic) and CO2 emissions (% of total fuel combustion) of Slovak Republic?
Provide a succinct answer. -10.68. In the year 1989, what is the difference between the CO2 emissions (% of total fuel combustion) in Congo (Democratic) and CO2 emissions (% of total fuel combustion) in South Africa?
Offer a terse response. 6.76. In the year 1989, what is the difference between the CO2 emissions (% of total fuel combustion) of Congo (Democratic) and CO2 emissions (% of total fuel combustion) of Togo?
Your response must be concise. 1.11. In the year 1989, what is the difference between the CO2 emissions (% of total fuel combustion) in Slovak Republic and CO2 emissions (% of total fuel combustion) in South Africa?
Offer a terse response. 17.44. In the year 1989, what is the difference between the CO2 emissions (% of total fuel combustion) of Slovak Republic and CO2 emissions (% of total fuel combustion) of Togo?
Ensure brevity in your answer.  11.79. In the year 1989, what is the difference between the CO2 emissions (% of total fuel combustion) in South Africa and CO2 emissions (% of total fuel combustion) in Togo?
Your response must be concise. -5.66. In the year 1990, what is the difference between the CO2 emissions (% of total fuel combustion) of Congo (Democratic) and CO2 emissions (% of total fuel combustion) of Slovak Republic?
Offer a very short reply. -15.91. In the year 1990, what is the difference between the CO2 emissions (% of total fuel combustion) of Congo (Democratic) and CO2 emissions (% of total fuel combustion) of South Africa?
Your answer should be very brief. 6.43. In the year 1990, what is the difference between the CO2 emissions (% of total fuel combustion) in Congo (Democratic) and CO2 emissions (% of total fuel combustion) in Togo?
Keep it short and to the point. 0.28. In the year 1990, what is the difference between the CO2 emissions (% of total fuel combustion) of Slovak Republic and CO2 emissions (% of total fuel combustion) of South Africa?
Your response must be concise. 22.34. In the year 1990, what is the difference between the CO2 emissions (% of total fuel combustion) of Slovak Republic and CO2 emissions (% of total fuel combustion) of Togo?
Make the answer very short. 16.2. In the year 1990, what is the difference between the CO2 emissions (% of total fuel combustion) of South Africa and CO2 emissions (% of total fuel combustion) of Togo?
Ensure brevity in your answer.  -6.14. In the year 1991, what is the difference between the CO2 emissions (% of total fuel combustion) of Congo (Democratic) and CO2 emissions (% of total fuel combustion) of Slovak Republic?
Your response must be concise. -19.84. In the year 1991, what is the difference between the CO2 emissions (% of total fuel combustion) of Congo (Democratic) and CO2 emissions (% of total fuel combustion) of South Africa?
Your answer should be very brief. -0.96. In the year 1991, what is the difference between the CO2 emissions (% of total fuel combustion) in Congo (Democratic) and CO2 emissions (% of total fuel combustion) in Togo?
Provide a short and direct response. -5.93. In the year 1991, what is the difference between the CO2 emissions (% of total fuel combustion) in Slovak Republic and CO2 emissions (% of total fuel combustion) in South Africa?
Give a very brief answer. 18.88. In the year 1991, what is the difference between the CO2 emissions (% of total fuel combustion) of Slovak Republic and CO2 emissions (% of total fuel combustion) of Togo?
Your answer should be very brief. 13.91. In the year 1991, what is the difference between the CO2 emissions (% of total fuel combustion) in South Africa and CO2 emissions (% of total fuel combustion) in Togo?
Ensure brevity in your answer.  -4.97. In the year 1992, what is the difference between the CO2 emissions (% of total fuel combustion) of Congo (Democratic) and CO2 emissions (% of total fuel combustion) of Slovak Republic?
Your response must be concise. -19.65. In the year 1992, what is the difference between the CO2 emissions (% of total fuel combustion) in Congo (Democratic) and CO2 emissions (% of total fuel combustion) in South Africa?
Your answer should be compact. -1.86. In the year 1992, what is the difference between the CO2 emissions (% of total fuel combustion) in Congo (Democratic) and CO2 emissions (% of total fuel combustion) in Togo?
Ensure brevity in your answer.  -10.68. In the year 1992, what is the difference between the CO2 emissions (% of total fuel combustion) of Slovak Republic and CO2 emissions (% of total fuel combustion) of South Africa?
Your answer should be compact. 17.8. In the year 1992, what is the difference between the CO2 emissions (% of total fuel combustion) in Slovak Republic and CO2 emissions (% of total fuel combustion) in Togo?
Your answer should be very brief. 8.98. In the year 1992, what is the difference between the CO2 emissions (% of total fuel combustion) of South Africa and CO2 emissions (% of total fuel combustion) of Togo?
Make the answer very short. -8.82. What is the ratio of the CO2 emissions (% of total fuel combustion) in Congo (Democratic) in 1985 to that in 1986?
Keep it short and to the point. 0.83. What is the ratio of the CO2 emissions (% of total fuel combustion) in Slovak Republic in 1985 to that in 1986?
Offer a terse response. 1.06. What is the ratio of the CO2 emissions (% of total fuel combustion) of South Africa in 1985 to that in 1986?
Provide a succinct answer. 1.2. What is the ratio of the CO2 emissions (% of total fuel combustion) in Togo in 1985 to that in 1986?
Ensure brevity in your answer.  1.24. What is the ratio of the CO2 emissions (% of total fuel combustion) of Congo (Democratic) in 1985 to that in 1987?
Offer a terse response. 0.94. What is the ratio of the CO2 emissions (% of total fuel combustion) of South Africa in 1985 to that in 1987?
Give a very brief answer. 1.24. What is the ratio of the CO2 emissions (% of total fuel combustion) in Togo in 1985 to that in 1987?
Provide a short and direct response. 1.34. What is the ratio of the CO2 emissions (% of total fuel combustion) of Congo (Democratic) in 1985 to that in 1988?
Give a very brief answer. 1.01. What is the ratio of the CO2 emissions (% of total fuel combustion) of Slovak Republic in 1985 to that in 1988?
Keep it short and to the point. 0.97. What is the ratio of the CO2 emissions (% of total fuel combustion) in South Africa in 1985 to that in 1988?
Provide a short and direct response. 1.12. What is the ratio of the CO2 emissions (% of total fuel combustion) of Togo in 1985 to that in 1988?
Your response must be concise. 1.29. What is the ratio of the CO2 emissions (% of total fuel combustion) in Congo (Democratic) in 1985 to that in 1989?
Make the answer very short. 0.94. What is the ratio of the CO2 emissions (% of total fuel combustion) of Slovak Republic in 1985 to that in 1989?
Keep it short and to the point. 0.98. What is the ratio of the CO2 emissions (% of total fuel combustion) of South Africa in 1985 to that in 1989?
Your answer should be compact. 0.99. What is the ratio of the CO2 emissions (% of total fuel combustion) in Togo in 1985 to that in 1989?
Give a very brief answer. 1.06. What is the ratio of the CO2 emissions (% of total fuel combustion) of Congo (Democratic) in 1985 to that in 1990?
Your response must be concise. 0.95. What is the ratio of the CO2 emissions (% of total fuel combustion) of Slovak Republic in 1985 to that in 1990?
Provide a succinct answer. 0.79. What is the ratio of the CO2 emissions (% of total fuel combustion) in South Africa in 1985 to that in 1990?
Offer a very short reply. 0.94. What is the ratio of the CO2 emissions (% of total fuel combustion) in Togo in 1985 to that in 1990?
Make the answer very short. 0.98. What is the ratio of the CO2 emissions (% of total fuel combustion) of Congo (Democratic) in 1985 to that in 1991?
Provide a short and direct response. 2.78. What is the ratio of the CO2 emissions (% of total fuel combustion) in Slovak Republic in 1985 to that in 1991?
Provide a short and direct response. 0.9. What is the ratio of the CO2 emissions (% of total fuel combustion) in South Africa in 1985 to that in 1991?
Keep it short and to the point. 0.88. What is the ratio of the CO2 emissions (% of total fuel combustion) in Togo in 1985 to that in 1991?
Your response must be concise. 1.08. What is the ratio of the CO2 emissions (% of total fuel combustion) of Congo (Democratic) in 1985 to that in 1992?
Your answer should be very brief. 3.61. What is the ratio of the CO2 emissions (% of total fuel combustion) in Slovak Republic in 1985 to that in 1992?
Your answer should be compact. 0.94. What is the ratio of the CO2 emissions (% of total fuel combustion) in South Africa in 1985 to that in 1992?
Keep it short and to the point. 0.88. What is the ratio of the CO2 emissions (% of total fuel combustion) in Togo in 1985 to that in 1992?
Make the answer very short. 0.77. What is the ratio of the CO2 emissions (% of total fuel combustion) in Congo (Democratic) in 1986 to that in 1987?
Your response must be concise. 1.13. What is the ratio of the CO2 emissions (% of total fuel combustion) of Slovak Republic in 1986 to that in 1987?
Provide a short and direct response. 0.95. What is the ratio of the CO2 emissions (% of total fuel combustion) in South Africa in 1986 to that in 1987?
Make the answer very short. 1.03. What is the ratio of the CO2 emissions (% of total fuel combustion) in Togo in 1986 to that in 1987?
Give a very brief answer. 1.08. What is the ratio of the CO2 emissions (% of total fuel combustion) in Congo (Democratic) in 1986 to that in 1988?
Give a very brief answer. 1.23. What is the ratio of the CO2 emissions (% of total fuel combustion) of Slovak Republic in 1986 to that in 1988?
Give a very brief answer. 0.91. What is the ratio of the CO2 emissions (% of total fuel combustion) in South Africa in 1986 to that in 1988?
Your answer should be very brief. 0.93. What is the ratio of the CO2 emissions (% of total fuel combustion) of Togo in 1986 to that in 1988?
Make the answer very short. 1.04. What is the ratio of the CO2 emissions (% of total fuel combustion) in Congo (Democratic) in 1986 to that in 1989?
Your answer should be compact. 1.14. What is the ratio of the CO2 emissions (% of total fuel combustion) in Slovak Republic in 1986 to that in 1989?
Ensure brevity in your answer.  0.93. What is the ratio of the CO2 emissions (% of total fuel combustion) of South Africa in 1986 to that in 1989?
Keep it short and to the point. 0.83. What is the ratio of the CO2 emissions (% of total fuel combustion) in Togo in 1986 to that in 1989?
Keep it short and to the point. 0.85. What is the ratio of the CO2 emissions (% of total fuel combustion) of Congo (Democratic) in 1986 to that in 1990?
Give a very brief answer. 1.15. What is the ratio of the CO2 emissions (% of total fuel combustion) of Slovak Republic in 1986 to that in 1990?
Your answer should be very brief. 0.75. What is the ratio of the CO2 emissions (% of total fuel combustion) in South Africa in 1986 to that in 1990?
Offer a very short reply. 0.78. What is the ratio of the CO2 emissions (% of total fuel combustion) in Togo in 1986 to that in 1990?
Provide a succinct answer. 0.79. What is the ratio of the CO2 emissions (% of total fuel combustion) in Congo (Democratic) in 1986 to that in 1991?
Provide a succinct answer. 3.37. What is the ratio of the CO2 emissions (% of total fuel combustion) in Slovak Republic in 1986 to that in 1991?
Give a very brief answer. 0.85. What is the ratio of the CO2 emissions (% of total fuel combustion) of South Africa in 1986 to that in 1991?
Ensure brevity in your answer.  0.74. What is the ratio of the CO2 emissions (% of total fuel combustion) of Togo in 1986 to that in 1991?
Your answer should be very brief. 0.87. What is the ratio of the CO2 emissions (% of total fuel combustion) in Congo (Democratic) in 1986 to that in 1992?
Your response must be concise. 4.38. What is the ratio of the CO2 emissions (% of total fuel combustion) in Slovak Republic in 1986 to that in 1992?
Keep it short and to the point. 0.89. What is the ratio of the CO2 emissions (% of total fuel combustion) in South Africa in 1986 to that in 1992?
Ensure brevity in your answer.  0.73. What is the ratio of the CO2 emissions (% of total fuel combustion) in Togo in 1986 to that in 1992?
Keep it short and to the point. 0.62. What is the ratio of the CO2 emissions (% of total fuel combustion) in Congo (Democratic) in 1987 to that in 1988?
Make the answer very short. 1.08. What is the ratio of the CO2 emissions (% of total fuel combustion) in Slovak Republic in 1987 to that in 1988?
Keep it short and to the point. 0.96. What is the ratio of the CO2 emissions (% of total fuel combustion) in South Africa in 1987 to that in 1988?
Ensure brevity in your answer.  0.91. What is the ratio of the CO2 emissions (% of total fuel combustion) in Togo in 1987 to that in 1988?
Make the answer very short. 0.96. What is the ratio of the CO2 emissions (% of total fuel combustion) in Slovak Republic in 1987 to that in 1989?
Make the answer very short. 0.98. What is the ratio of the CO2 emissions (% of total fuel combustion) of South Africa in 1987 to that in 1989?
Keep it short and to the point. 0.8. What is the ratio of the CO2 emissions (% of total fuel combustion) in Togo in 1987 to that in 1989?
Give a very brief answer. 0.78. What is the ratio of the CO2 emissions (% of total fuel combustion) in Congo (Democratic) in 1987 to that in 1990?
Provide a succinct answer. 1.01. What is the ratio of the CO2 emissions (% of total fuel combustion) in Slovak Republic in 1987 to that in 1990?
Your answer should be compact. 0.79. What is the ratio of the CO2 emissions (% of total fuel combustion) of South Africa in 1987 to that in 1990?
Offer a terse response. 0.76. What is the ratio of the CO2 emissions (% of total fuel combustion) of Togo in 1987 to that in 1990?
Your answer should be compact. 0.73. What is the ratio of the CO2 emissions (% of total fuel combustion) of Congo (Democratic) in 1987 to that in 1991?
Provide a short and direct response. 2.97. What is the ratio of the CO2 emissions (% of total fuel combustion) of Slovak Republic in 1987 to that in 1991?
Your response must be concise. 0.9. What is the ratio of the CO2 emissions (% of total fuel combustion) of South Africa in 1987 to that in 1991?
Provide a succinct answer. 0.72. What is the ratio of the CO2 emissions (% of total fuel combustion) of Togo in 1987 to that in 1991?
Your answer should be very brief. 0.8. What is the ratio of the CO2 emissions (% of total fuel combustion) in Congo (Democratic) in 1987 to that in 1992?
Make the answer very short. 3.86. What is the ratio of the CO2 emissions (% of total fuel combustion) of Slovak Republic in 1987 to that in 1992?
Provide a short and direct response. 0.94. What is the ratio of the CO2 emissions (% of total fuel combustion) of South Africa in 1987 to that in 1992?
Make the answer very short. 0.71. What is the ratio of the CO2 emissions (% of total fuel combustion) in Togo in 1987 to that in 1992?
Provide a short and direct response. 0.57. What is the ratio of the CO2 emissions (% of total fuel combustion) in Congo (Democratic) in 1988 to that in 1989?
Your answer should be very brief. 0.93. What is the ratio of the CO2 emissions (% of total fuel combustion) of Slovak Republic in 1988 to that in 1989?
Give a very brief answer. 1.01. What is the ratio of the CO2 emissions (% of total fuel combustion) in South Africa in 1988 to that in 1989?
Keep it short and to the point. 0.89. What is the ratio of the CO2 emissions (% of total fuel combustion) of Togo in 1988 to that in 1989?
Make the answer very short. 0.82. What is the ratio of the CO2 emissions (% of total fuel combustion) in Congo (Democratic) in 1988 to that in 1990?
Your answer should be compact. 0.94. What is the ratio of the CO2 emissions (% of total fuel combustion) of Slovak Republic in 1988 to that in 1990?
Offer a terse response. 0.82. What is the ratio of the CO2 emissions (% of total fuel combustion) in South Africa in 1988 to that in 1990?
Your answer should be very brief. 0.84. What is the ratio of the CO2 emissions (% of total fuel combustion) of Togo in 1988 to that in 1990?
Keep it short and to the point. 0.76. What is the ratio of the CO2 emissions (% of total fuel combustion) of Congo (Democratic) in 1988 to that in 1991?
Keep it short and to the point. 2.75. What is the ratio of the CO2 emissions (% of total fuel combustion) in Slovak Republic in 1988 to that in 1991?
Provide a short and direct response. 0.93. What is the ratio of the CO2 emissions (% of total fuel combustion) in South Africa in 1988 to that in 1991?
Offer a very short reply. 0.79. What is the ratio of the CO2 emissions (% of total fuel combustion) in Togo in 1988 to that in 1991?
Keep it short and to the point. 0.83. What is the ratio of the CO2 emissions (% of total fuel combustion) of Congo (Democratic) in 1988 to that in 1992?
Your answer should be compact. 3.57. What is the ratio of the CO2 emissions (% of total fuel combustion) in Slovak Republic in 1988 to that in 1992?
Make the answer very short. 0.97. What is the ratio of the CO2 emissions (% of total fuel combustion) of South Africa in 1988 to that in 1992?
Provide a succinct answer. 0.78. What is the ratio of the CO2 emissions (% of total fuel combustion) in Togo in 1988 to that in 1992?
Give a very brief answer. 0.59. What is the ratio of the CO2 emissions (% of total fuel combustion) in Congo (Democratic) in 1989 to that in 1990?
Offer a very short reply. 1.01. What is the ratio of the CO2 emissions (% of total fuel combustion) of Slovak Republic in 1989 to that in 1990?
Your answer should be very brief. 0.81. What is the ratio of the CO2 emissions (% of total fuel combustion) in South Africa in 1989 to that in 1990?
Offer a very short reply. 0.95. What is the ratio of the CO2 emissions (% of total fuel combustion) in Togo in 1989 to that in 1990?
Offer a very short reply. 0.93. What is the ratio of the CO2 emissions (% of total fuel combustion) of Congo (Democratic) in 1989 to that in 1991?
Give a very brief answer. 2.96. What is the ratio of the CO2 emissions (% of total fuel combustion) of Slovak Republic in 1989 to that in 1991?
Provide a succinct answer. 0.92. What is the ratio of the CO2 emissions (% of total fuel combustion) of South Africa in 1989 to that in 1991?
Give a very brief answer. 0.89. What is the ratio of the CO2 emissions (% of total fuel combustion) of Togo in 1989 to that in 1991?
Your answer should be compact. 1.02. What is the ratio of the CO2 emissions (% of total fuel combustion) in Congo (Democratic) in 1989 to that in 1992?
Keep it short and to the point. 3.85. What is the ratio of the CO2 emissions (% of total fuel combustion) in Slovak Republic in 1989 to that in 1992?
Your answer should be compact. 0.96. What is the ratio of the CO2 emissions (% of total fuel combustion) in South Africa in 1989 to that in 1992?
Ensure brevity in your answer.  0.88. What is the ratio of the CO2 emissions (% of total fuel combustion) of Togo in 1989 to that in 1992?
Your answer should be compact. 0.73. What is the ratio of the CO2 emissions (% of total fuel combustion) in Congo (Democratic) in 1990 to that in 1991?
Provide a succinct answer. 2.94. What is the ratio of the CO2 emissions (% of total fuel combustion) of Slovak Republic in 1990 to that in 1991?
Offer a very short reply. 1.14. What is the ratio of the CO2 emissions (% of total fuel combustion) in South Africa in 1990 to that in 1991?
Your answer should be very brief. 0.94. What is the ratio of the CO2 emissions (% of total fuel combustion) in Togo in 1990 to that in 1991?
Keep it short and to the point. 1.09. What is the ratio of the CO2 emissions (% of total fuel combustion) in Congo (Democratic) in 1990 to that in 1992?
Your answer should be very brief. 3.81. What is the ratio of the CO2 emissions (% of total fuel combustion) of Slovak Republic in 1990 to that in 1992?
Keep it short and to the point. 1.19. What is the ratio of the CO2 emissions (% of total fuel combustion) of South Africa in 1990 to that in 1992?
Ensure brevity in your answer.  0.93. What is the ratio of the CO2 emissions (% of total fuel combustion) in Togo in 1990 to that in 1992?
Give a very brief answer. 0.78. What is the ratio of the CO2 emissions (% of total fuel combustion) in Congo (Democratic) in 1991 to that in 1992?
Provide a succinct answer. 1.3. What is the ratio of the CO2 emissions (% of total fuel combustion) in Slovak Republic in 1991 to that in 1992?
Provide a short and direct response. 1.05. What is the ratio of the CO2 emissions (% of total fuel combustion) in South Africa in 1991 to that in 1992?
Provide a short and direct response. 0.99. What is the ratio of the CO2 emissions (% of total fuel combustion) of Togo in 1991 to that in 1992?
Your answer should be very brief. 0.71. What is the difference between the highest and the second highest CO2 emissions (% of total fuel combustion) of Congo (Democratic)?
Your response must be concise. 1.47. What is the difference between the highest and the second highest CO2 emissions (% of total fuel combustion) of Slovak Republic?
Give a very brief answer. 3.2. What is the difference between the highest and the second highest CO2 emissions (% of total fuel combustion) in South Africa?
Keep it short and to the point. 0.05. What is the difference between the highest and the second highest CO2 emissions (% of total fuel combustion) of Togo?
Offer a terse response. 2.99. What is the difference between the highest and the lowest CO2 emissions (% of total fuel combustion) in Congo (Democratic)?
Give a very brief answer. 9.58. What is the difference between the highest and the lowest CO2 emissions (% of total fuel combustion) of Slovak Republic?
Your answer should be very brief. 6.72. What is the difference between the highest and the lowest CO2 emissions (% of total fuel combustion) of South Africa?
Offer a very short reply. 1.37. What is the difference between the highest and the lowest CO2 emissions (% of total fuel combustion) in Togo?
Ensure brevity in your answer.  5.82. 